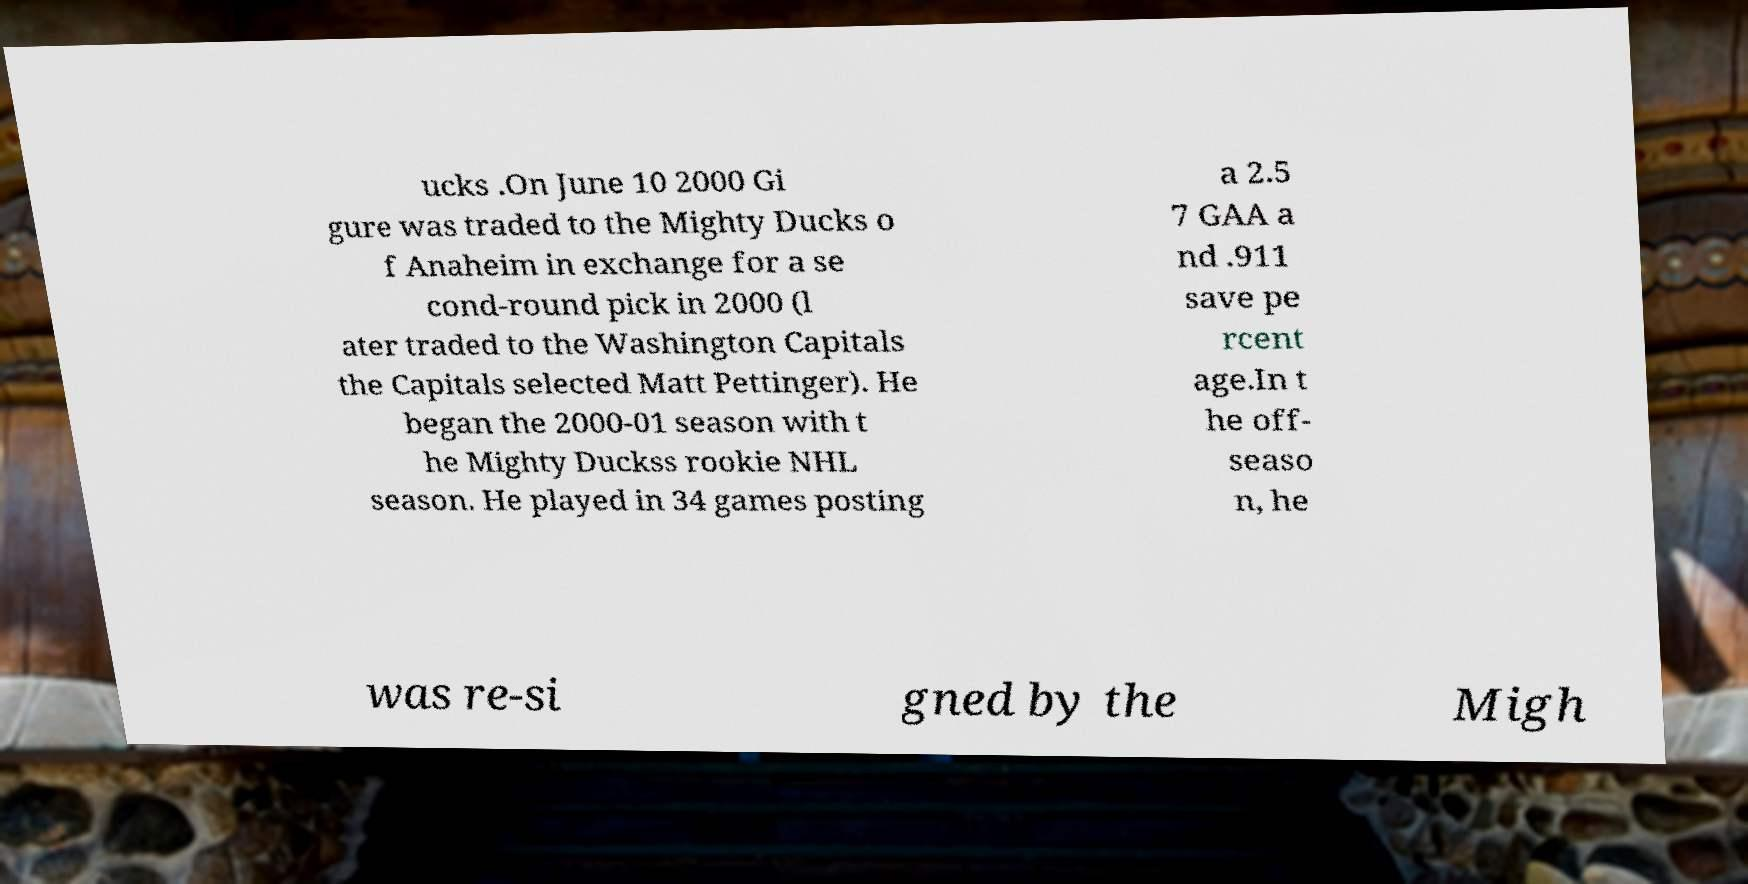What messages or text are displayed in this image? I need them in a readable, typed format. ucks .On June 10 2000 Gi gure was traded to the Mighty Ducks o f Anaheim in exchange for a se cond-round pick in 2000 (l ater traded to the Washington Capitals the Capitals selected Matt Pettinger). He began the 2000-01 season with t he Mighty Duckss rookie NHL season. He played in 34 games posting a 2.5 7 GAA a nd .911 save pe rcent age.In t he off- seaso n, he was re-si gned by the Migh 